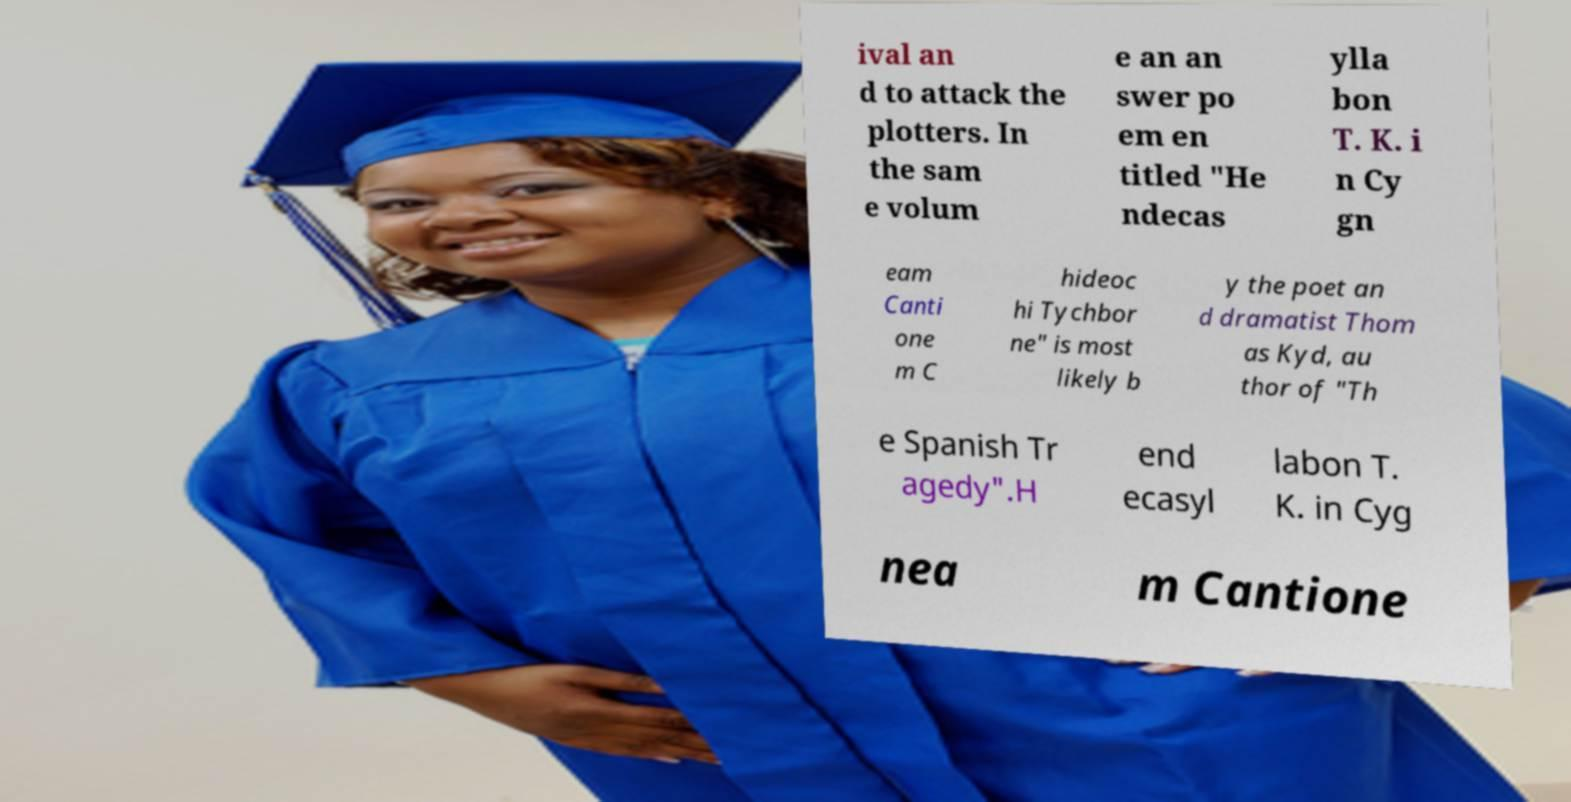Please read and relay the text visible in this image. What does it say? ival an d to attack the plotters. In the sam e volum e an an swer po em en titled "He ndecas ylla bon T. K. i n Cy gn eam Canti one m C hideoc hi Tychbor ne" is most likely b y the poet an d dramatist Thom as Kyd, au thor of "Th e Spanish Tr agedy".H end ecasyl labon T. K. in Cyg nea m Cantione 